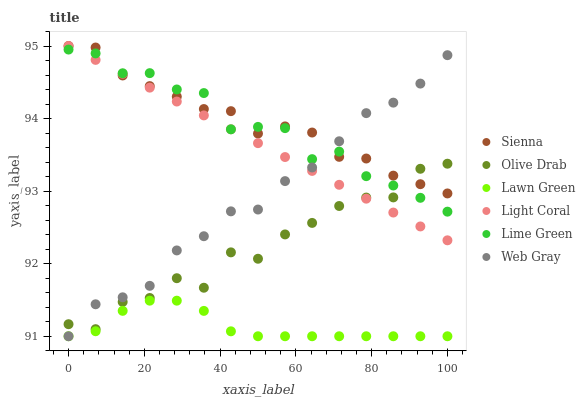Does Lawn Green have the minimum area under the curve?
Answer yes or no. Yes. Does Sienna have the maximum area under the curve?
Answer yes or no. Yes. Does Web Gray have the minimum area under the curve?
Answer yes or no. No. Does Web Gray have the maximum area under the curve?
Answer yes or no. No. Is Light Coral the smoothest?
Answer yes or no. Yes. Is Olive Drab the roughest?
Answer yes or no. Yes. Is Web Gray the smoothest?
Answer yes or no. No. Is Web Gray the roughest?
Answer yes or no. No. Does Lawn Green have the lowest value?
Answer yes or no. Yes. Does Light Coral have the lowest value?
Answer yes or no. No. Does Sienna have the highest value?
Answer yes or no. Yes. Does Web Gray have the highest value?
Answer yes or no. No. Is Lawn Green less than Sienna?
Answer yes or no. Yes. Is Light Coral greater than Lawn Green?
Answer yes or no. Yes. Does Lime Green intersect Light Coral?
Answer yes or no. Yes. Is Lime Green less than Light Coral?
Answer yes or no. No. Is Lime Green greater than Light Coral?
Answer yes or no. No. Does Lawn Green intersect Sienna?
Answer yes or no. No. 